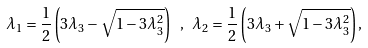Convert formula to latex. <formula><loc_0><loc_0><loc_500><loc_500>\lambda _ { 1 } = \frac { 1 } { 2 } \left ( 3 \lambda _ { 3 } - \sqrt { 1 - 3 \lambda _ { 3 } ^ { 2 } } \right ) \ , \ \lambda _ { 2 } = \frac { 1 } { 2 } \left ( 3 \lambda _ { 3 } + \sqrt { 1 - 3 \lambda _ { 3 } ^ { 2 } } \right ) ,</formula> 